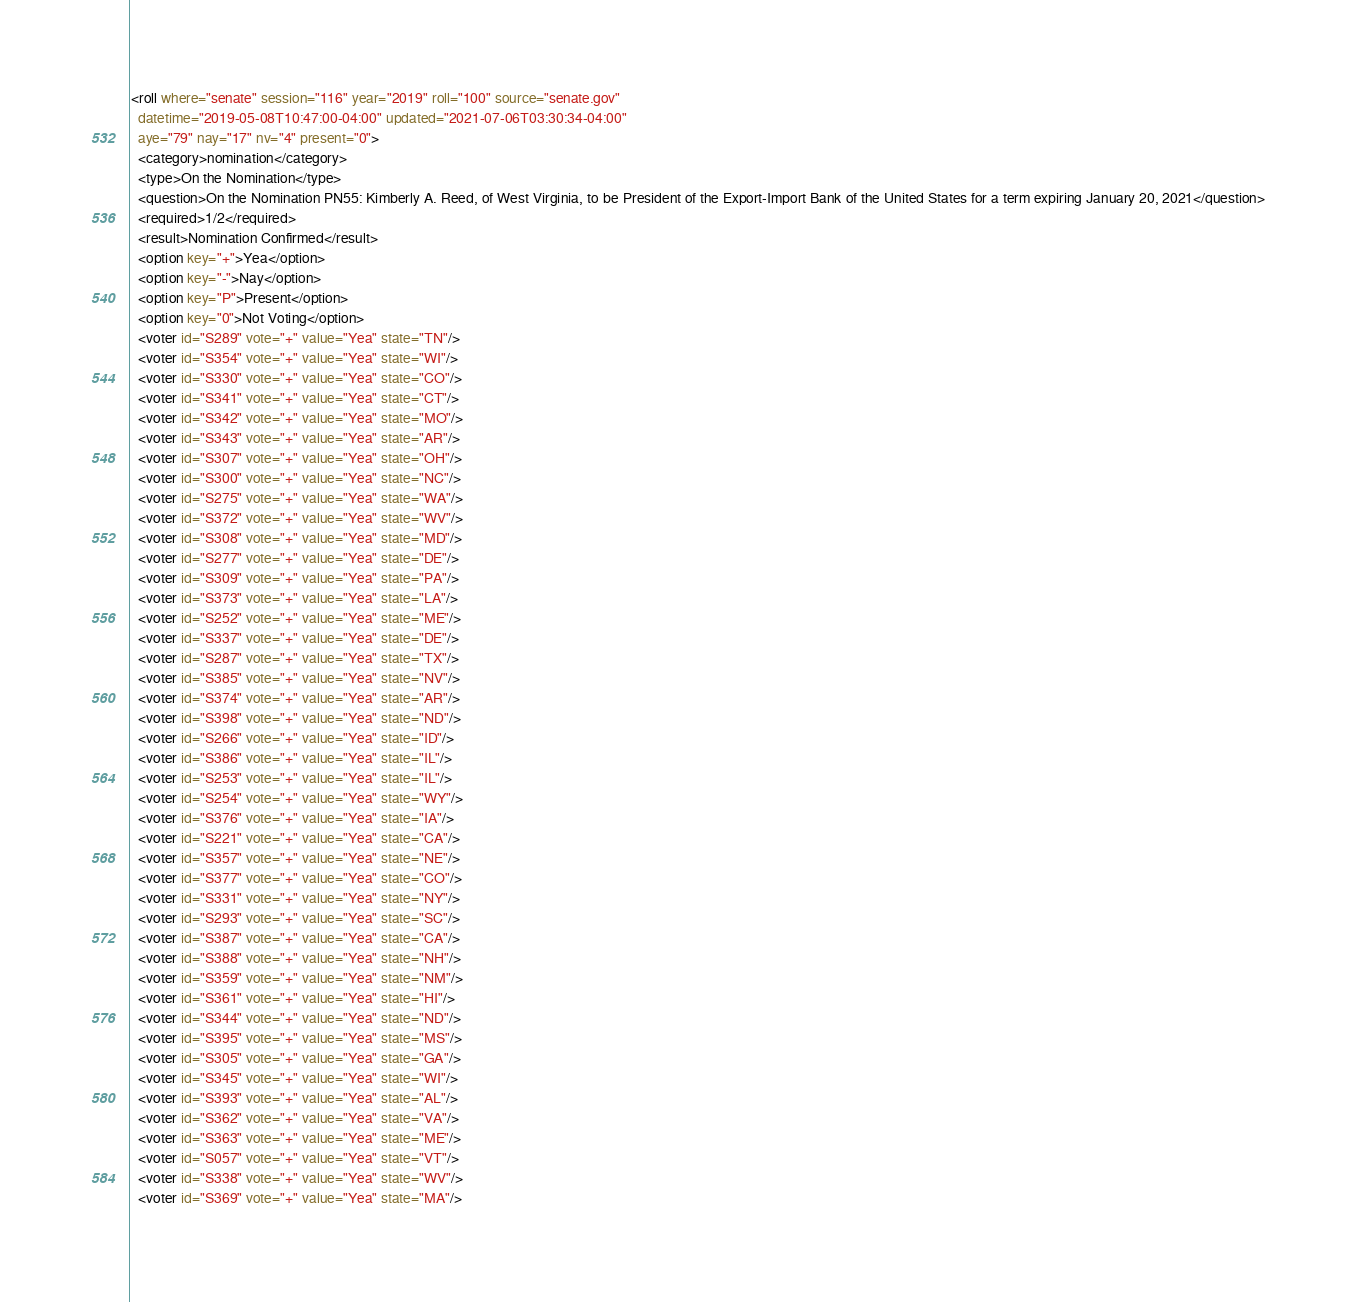<code> <loc_0><loc_0><loc_500><loc_500><_XML_><roll where="senate" session="116" year="2019" roll="100" source="senate.gov"
  datetime="2019-05-08T10:47:00-04:00" updated="2021-07-06T03:30:34-04:00"
  aye="79" nay="17" nv="4" present="0">
  <category>nomination</category>
  <type>On the Nomination</type>
  <question>On the Nomination PN55: Kimberly A. Reed, of West Virginia, to be President of the Export-Import Bank of the United States for a term expiring January 20, 2021</question>
  <required>1/2</required>
  <result>Nomination Confirmed</result>
  <option key="+">Yea</option>
  <option key="-">Nay</option>
  <option key="P">Present</option>
  <option key="0">Not Voting</option>
  <voter id="S289" vote="+" value="Yea" state="TN"/>
  <voter id="S354" vote="+" value="Yea" state="WI"/>
  <voter id="S330" vote="+" value="Yea" state="CO"/>
  <voter id="S341" vote="+" value="Yea" state="CT"/>
  <voter id="S342" vote="+" value="Yea" state="MO"/>
  <voter id="S343" vote="+" value="Yea" state="AR"/>
  <voter id="S307" vote="+" value="Yea" state="OH"/>
  <voter id="S300" vote="+" value="Yea" state="NC"/>
  <voter id="S275" vote="+" value="Yea" state="WA"/>
  <voter id="S372" vote="+" value="Yea" state="WV"/>
  <voter id="S308" vote="+" value="Yea" state="MD"/>
  <voter id="S277" vote="+" value="Yea" state="DE"/>
  <voter id="S309" vote="+" value="Yea" state="PA"/>
  <voter id="S373" vote="+" value="Yea" state="LA"/>
  <voter id="S252" vote="+" value="Yea" state="ME"/>
  <voter id="S337" vote="+" value="Yea" state="DE"/>
  <voter id="S287" vote="+" value="Yea" state="TX"/>
  <voter id="S385" vote="+" value="Yea" state="NV"/>
  <voter id="S374" vote="+" value="Yea" state="AR"/>
  <voter id="S398" vote="+" value="Yea" state="ND"/>
  <voter id="S266" vote="+" value="Yea" state="ID"/>
  <voter id="S386" vote="+" value="Yea" state="IL"/>
  <voter id="S253" vote="+" value="Yea" state="IL"/>
  <voter id="S254" vote="+" value="Yea" state="WY"/>
  <voter id="S376" vote="+" value="Yea" state="IA"/>
  <voter id="S221" vote="+" value="Yea" state="CA"/>
  <voter id="S357" vote="+" value="Yea" state="NE"/>
  <voter id="S377" vote="+" value="Yea" state="CO"/>
  <voter id="S331" vote="+" value="Yea" state="NY"/>
  <voter id="S293" vote="+" value="Yea" state="SC"/>
  <voter id="S387" vote="+" value="Yea" state="CA"/>
  <voter id="S388" vote="+" value="Yea" state="NH"/>
  <voter id="S359" vote="+" value="Yea" state="NM"/>
  <voter id="S361" vote="+" value="Yea" state="HI"/>
  <voter id="S344" vote="+" value="Yea" state="ND"/>
  <voter id="S395" vote="+" value="Yea" state="MS"/>
  <voter id="S305" vote="+" value="Yea" state="GA"/>
  <voter id="S345" vote="+" value="Yea" state="WI"/>
  <voter id="S393" vote="+" value="Yea" state="AL"/>
  <voter id="S362" vote="+" value="Yea" state="VA"/>
  <voter id="S363" vote="+" value="Yea" state="ME"/>
  <voter id="S057" vote="+" value="Yea" state="VT"/>
  <voter id="S338" vote="+" value="Yea" state="WV"/>
  <voter id="S369" vote="+" value="Yea" state="MA"/></code> 